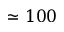Convert formula to latex. <formula><loc_0><loc_0><loc_500><loc_500>\simeq 1 0 0</formula> 